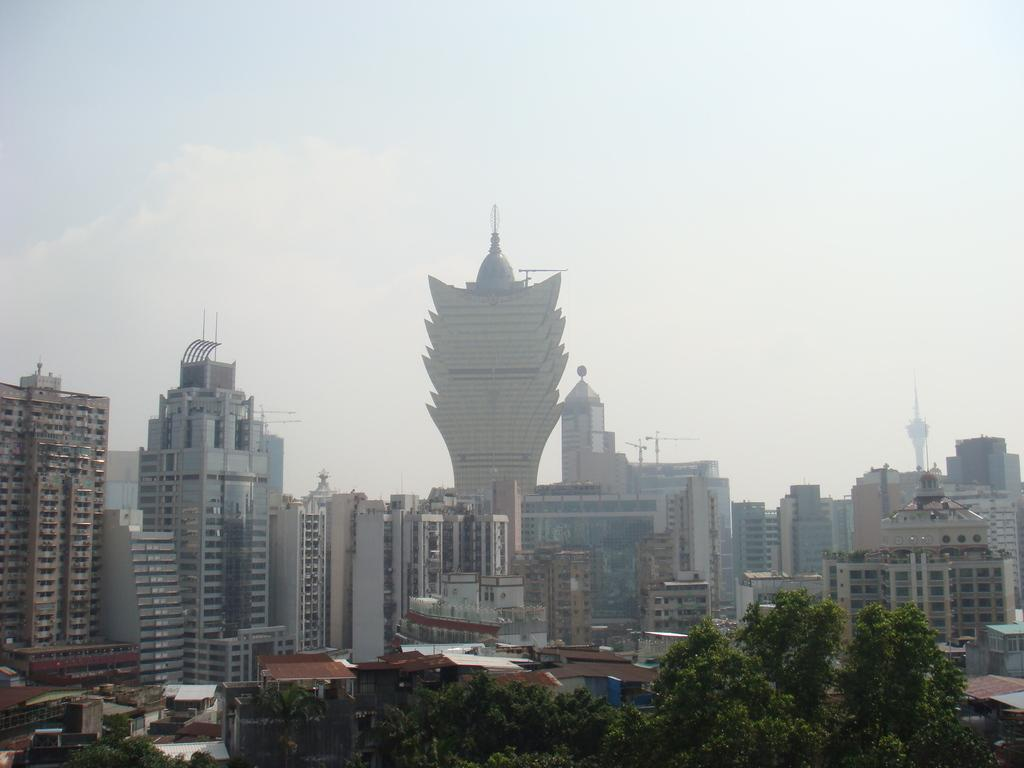What type of structures can be seen in the image? There are buildings with windows and houses with roofs in the image. What is present in the image that provides shade or protection from the elements? The houses have roofs in the image. What type of vegetation can be seen in the image? There is a group of trees in the image. What is visible in the background of the image? The sky is visible in the image. What is the condition of the sky in the image? The sky appears to be cloudy in the image. Can you see any teeth marks on the trees in the image? There are no teeth marks visible on the trees in the image. What type of pot is being used to water the buildings in the image? There is no pot present in the image, and the buildings are not being watered. 